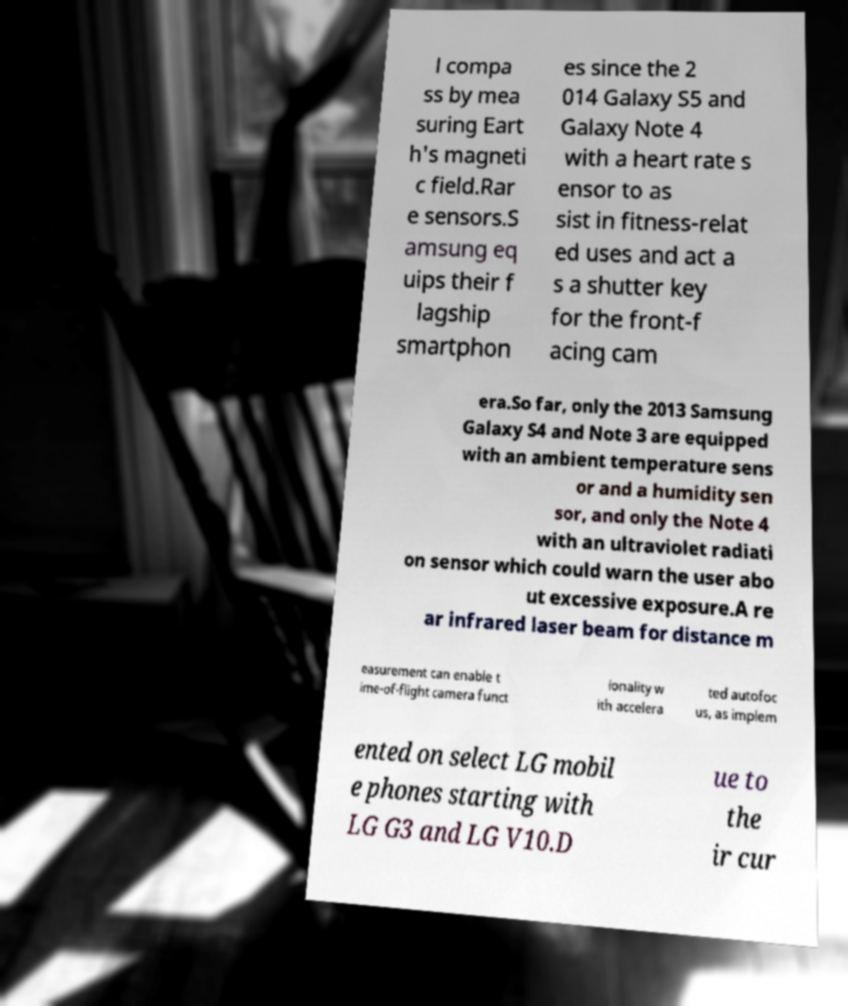Please identify and transcribe the text found in this image. l compa ss by mea suring Eart h's magneti c field.Rar e sensors.S amsung eq uips their f lagship smartphon es since the 2 014 Galaxy S5 and Galaxy Note 4 with a heart rate s ensor to as sist in fitness-relat ed uses and act a s a shutter key for the front-f acing cam era.So far, only the 2013 Samsung Galaxy S4 and Note 3 are equipped with an ambient temperature sens or and a humidity sen sor, and only the Note 4 with an ultraviolet radiati on sensor which could warn the user abo ut excessive exposure.A re ar infrared laser beam for distance m easurement can enable t ime-of-flight camera funct ionality w ith accelera ted autofoc us, as implem ented on select LG mobil e phones starting with LG G3 and LG V10.D ue to the ir cur 